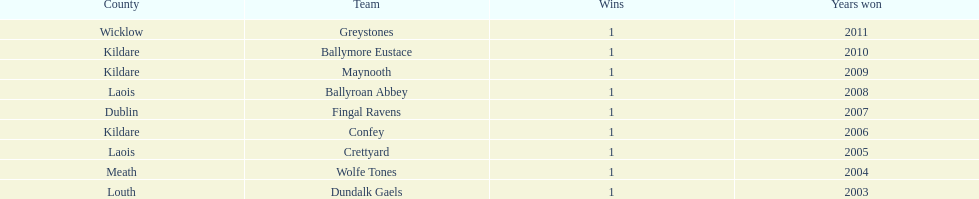Which county had the most number of wins? Kildare. 